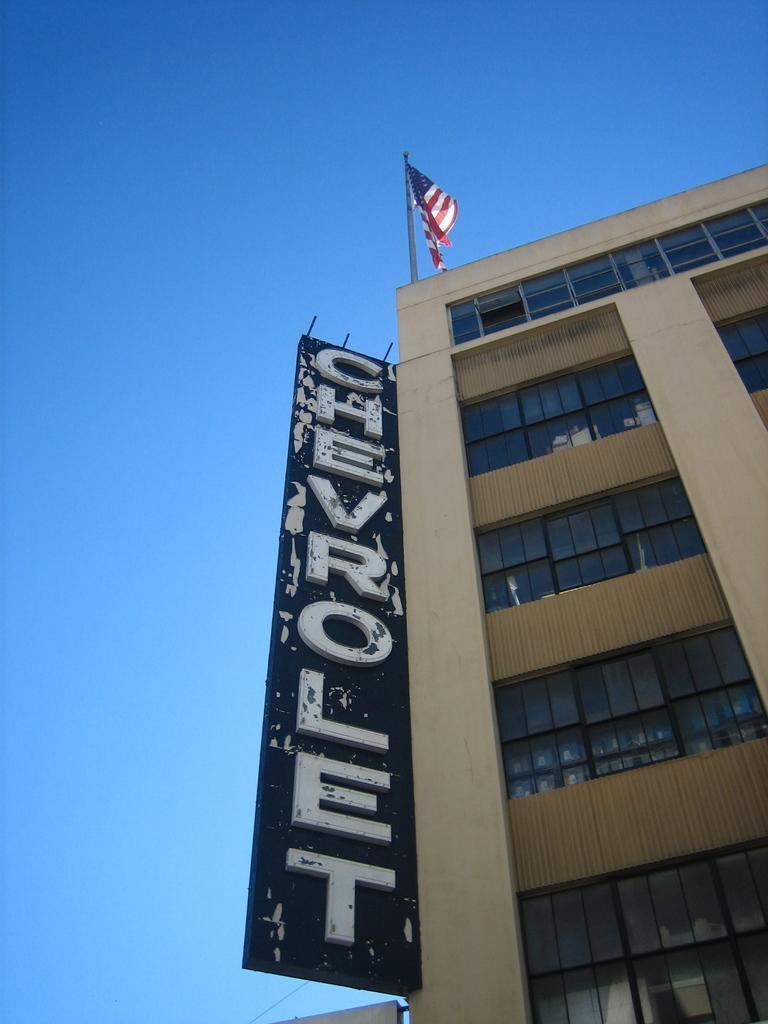Could you give a brief overview of what you see in this image? In the image I can see a building to which there are some windows, board and a flag on it. 